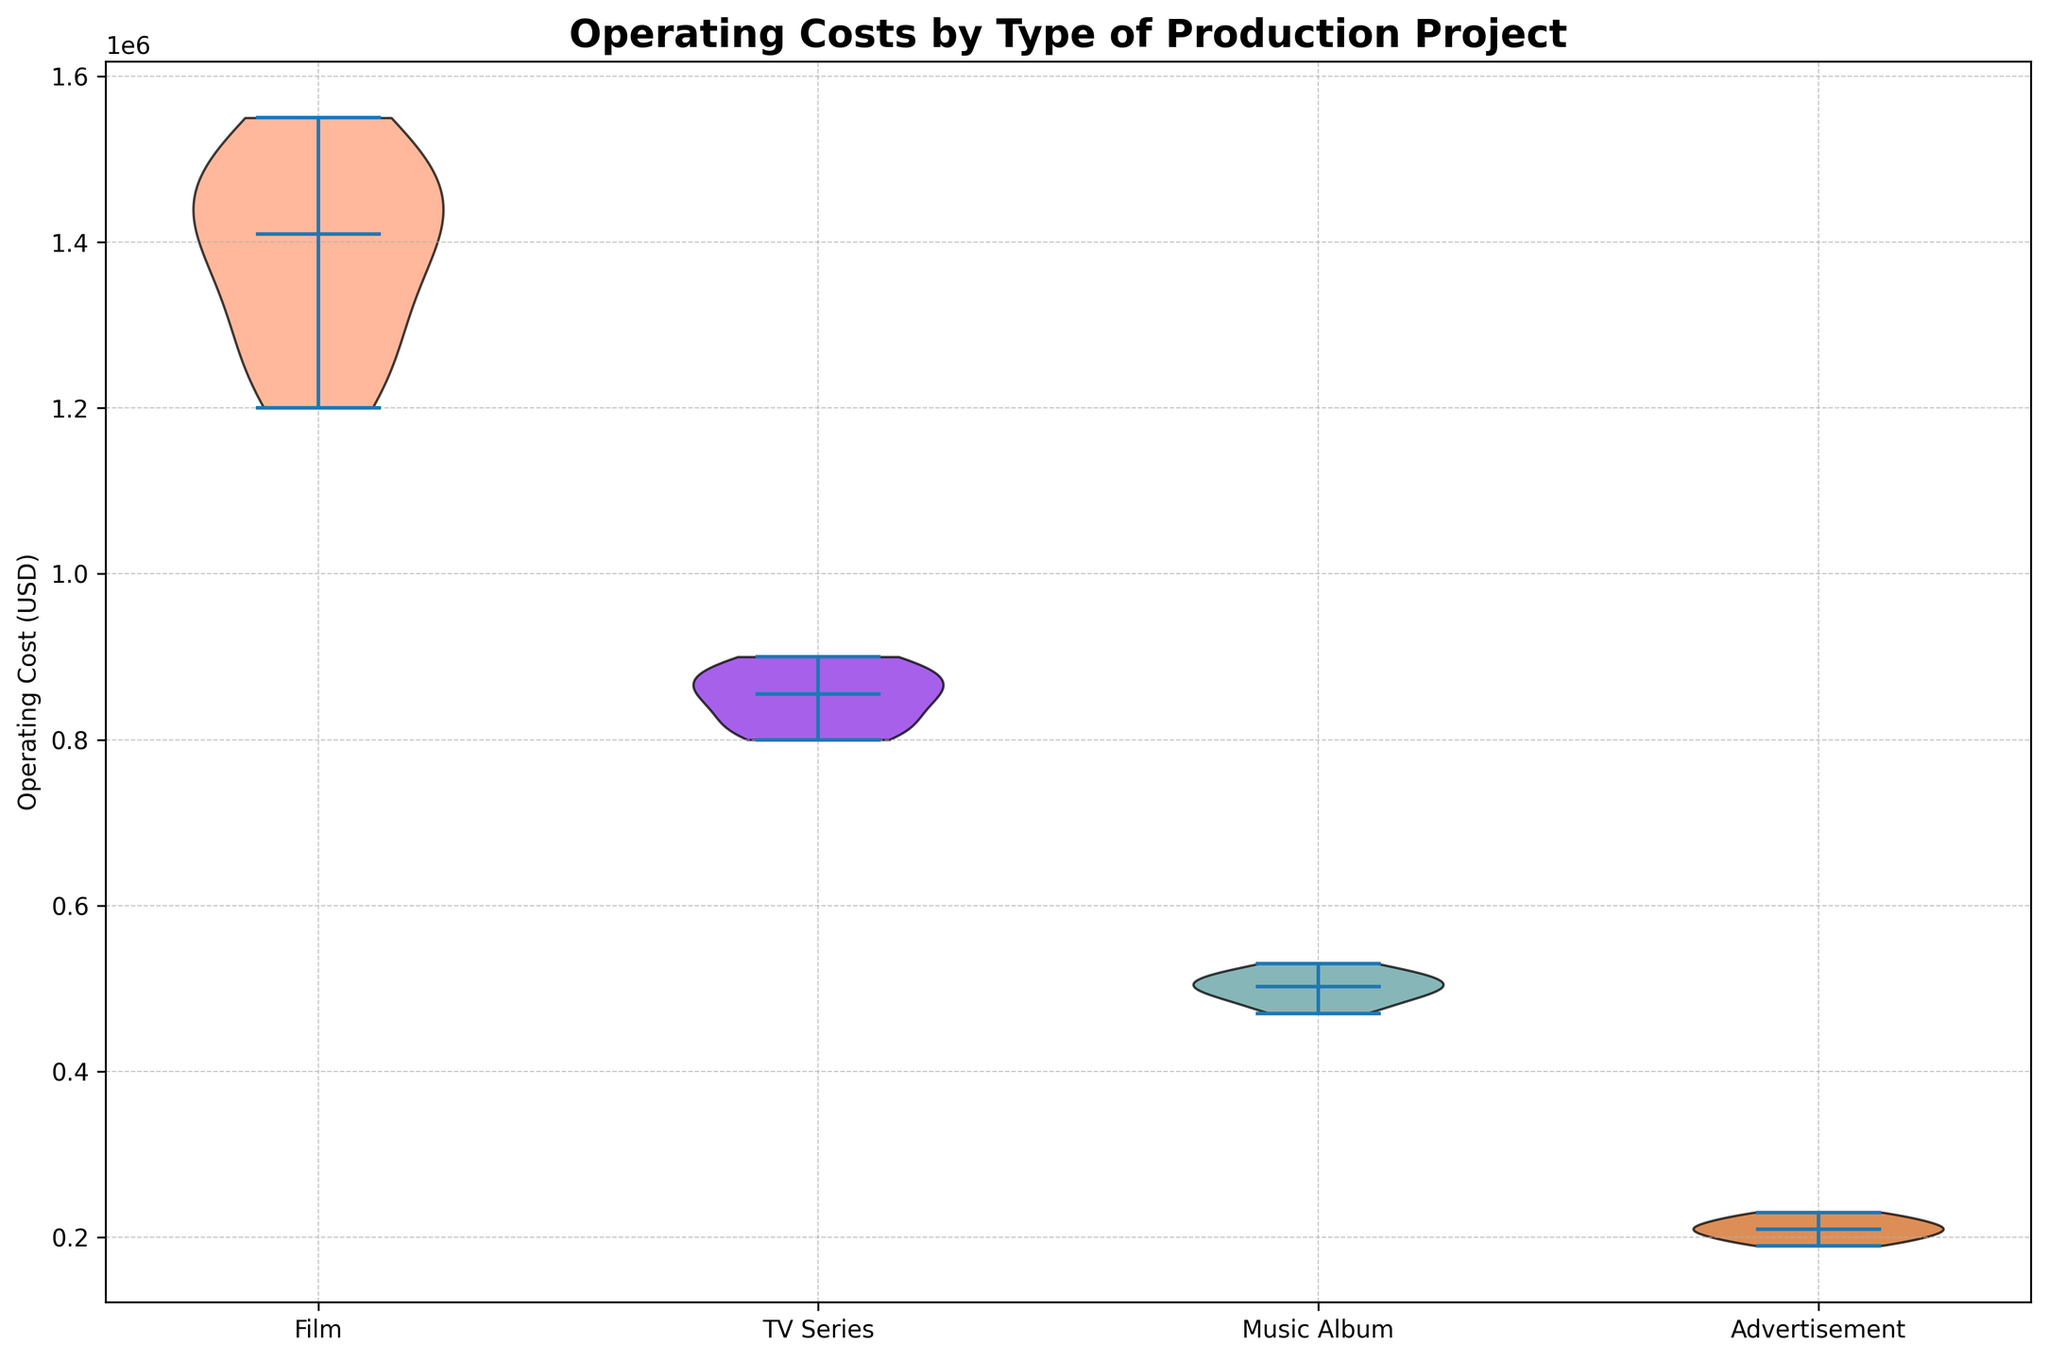Which type of production project has the highest median operating cost? The visually represented median lines in the violin plots show that the film category has the highest median operating cost as it is the most elevated line
Answer: Film What is the pattern of operating cost variability among the different types of production projects? By examining the width of the violin plots, films show the highest variability, TV series moderate variability, music albums lower variability, and advertisements the least variability
Answer: Film > TV Series > Music Album > Advertisement How does the median operating cost of music albums compare to that of TV series? By checking the position of the median lines, music albums have a median line noticeably lower than that of TV series, indicating a lower median operating cost
Answer: Music Album < TV Series Which type of production project has the least variability in operating costs? The narrowest violin plot indicates least variability, and advertisements have the narrowest plot among all categories
Answer: Advertisement Are there any overlapping ranges of operating costs between film and TV series? Both violin plots extend over different ranges without significant overlap, film ranges roughly from $1,200,000 to $1,550,000, while TV series ranges from $800,000 to $900,000
Answer: No significant overlap What is the approximate range of operating costs for advertisements? The advertisement violin plot stretches from about $190,000 to $230,000, which shows the approximate range of costs in this category
Answer: $190,000 - $230,000 How does the spread of operating costs for TV series compare to music albums? The violin plot for the TV series is wider than that for music albums, indicating a broader spread of operating costs
Answer: TV Series > Music Album Which type of production project has a median operating cost close to $500,000? Among the median lines, the music album's median line is positioned near $500,000, matching this criterion
Answer: Music Album Does the median operating cost of advertisements exceed $200,000? By observing the median line in the advertisement violin plot, it lies above the $200,000 mark, confirming it exceeds $200,000
Answer: Yes 